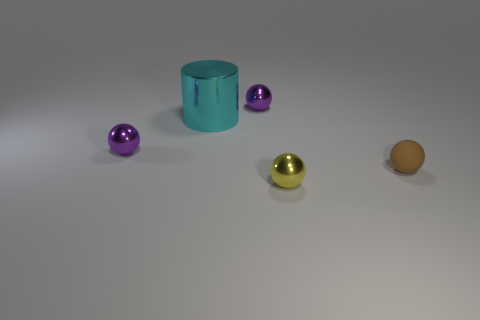Add 3 brown matte objects. How many objects exist? 8 Subtract all balls. How many objects are left? 1 Subtract 0 blue cylinders. How many objects are left? 5 Subtract all big metal cubes. Subtract all tiny purple objects. How many objects are left? 3 Add 3 small matte balls. How many small matte balls are left? 4 Add 2 brown matte balls. How many brown matte balls exist? 3 